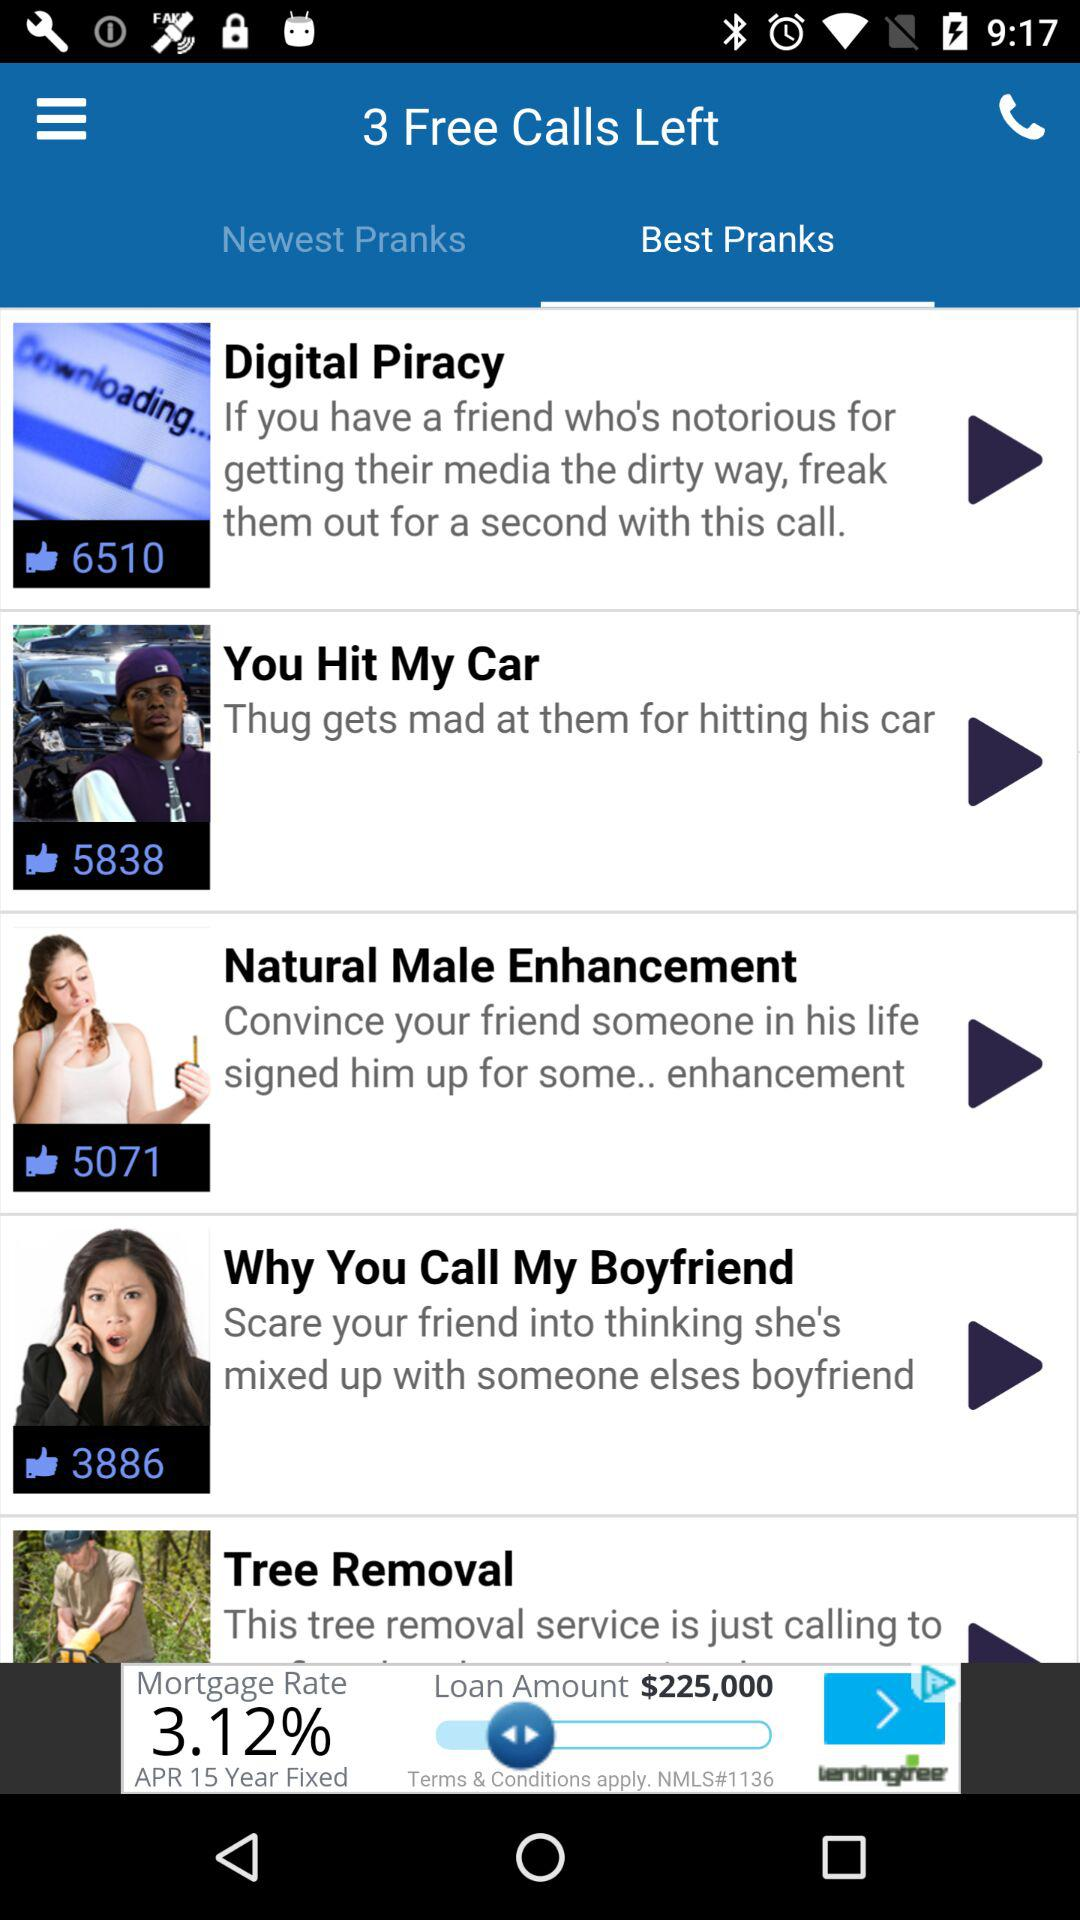How many prank calls are there in total?
Answer the question using a single word or phrase. 5 